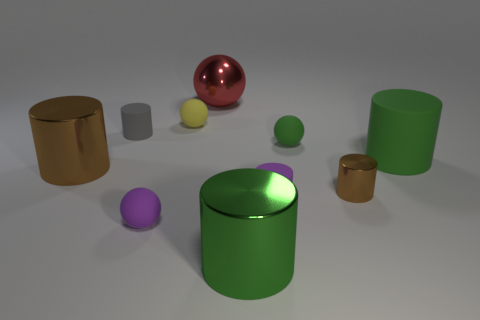Subtract 1 cylinders. How many cylinders are left? 5 Subtract all purple cylinders. How many cylinders are left? 5 Subtract all small gray matte cylinders. How many cylinders are left? 5 Subtract all cyan cylinders. Subtract all red spheres. How many cylinders are left? 6 Subtract all cylinders. How many objects are left? 4 Add 7 big brown things. How many big brown things are left? 8 Add 9 red objects. How many red objects exist? 10 Subtract 0 yellow cubes. How many objects are left? 10 Subtract all big cyan cylinders. Subtract all metallic objects. How many objects are left? 6 